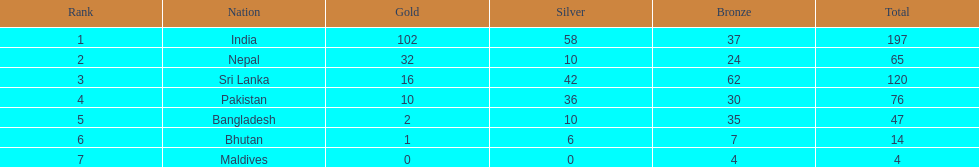What is the collective sum of gold medals won by the seven nations? 163. Could you parse the entire table? {'header': ['Rank', 'Nation', 'Gold', 'Silver', 'Bronze', 'Total'], 'rows': [['1', 'India', '102', '58', '37', '197'], ['2', 'Nepal', '32', '10', '24', '65'], ['3', 'Sri Lanka', '16', '42', '62', '120'], ['4', 'Pakistan', '10', '36', '30', '76'], ['5', 'Bangladesh', '2', '10', '35', '47'], ['6', 'Bhutan', '1', '6', '7', '14'], ['7', 'Maldives', '0', '0', '4', '4']]} 